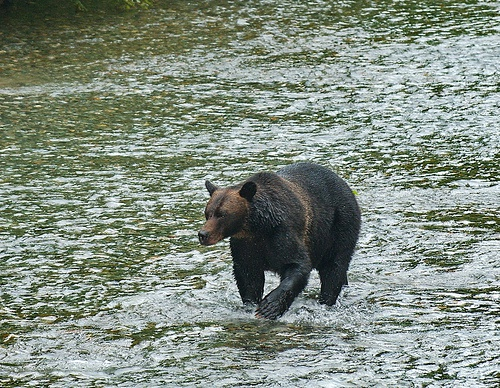Describe the objects in this image and their specific colors. I can see a bear in black, gray, purple, and darkgray tones in this image. 